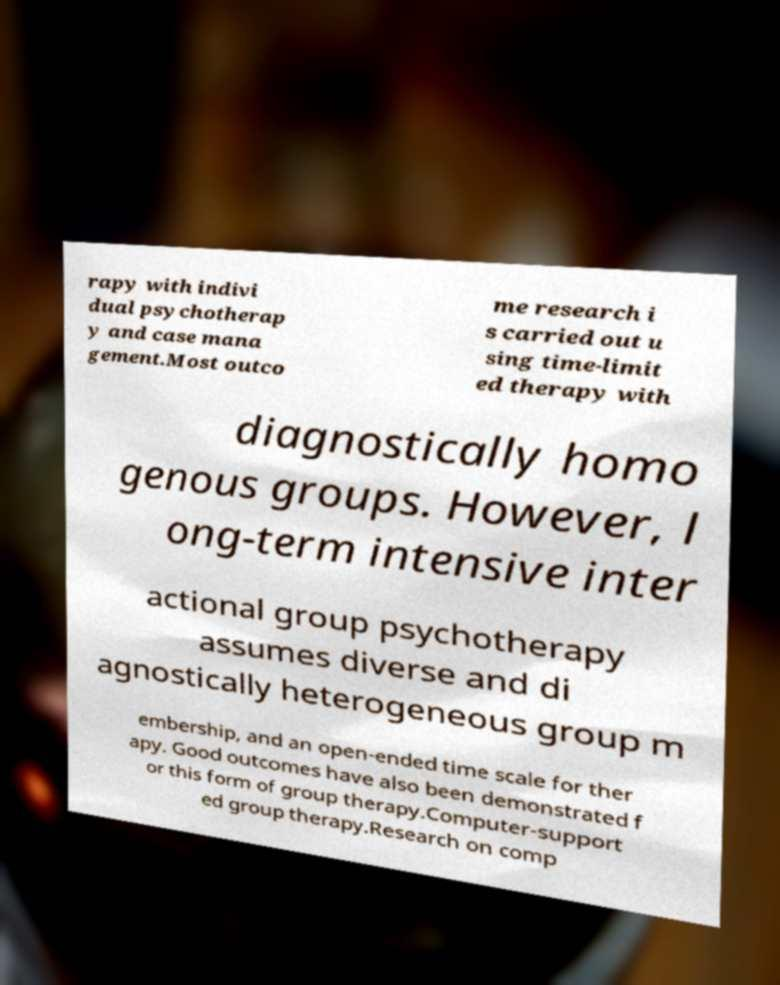Please read and relay the text visible in this image. What does it say? rapy with indivi dual psychotherap y and case mana gement.Most outco me research i s carried out u sing time-limit ed therapy with diagnostically homo genous groups. However, l ong-term intensive inter actional group psychotherapy assumes diverse and di agnostically heterogeneous group m embership, and an open-ended time scale for ther apy. Good outcomes have also been demonstrated f or this form of group therapy.Computer-support ed group therapy.Research on comp 